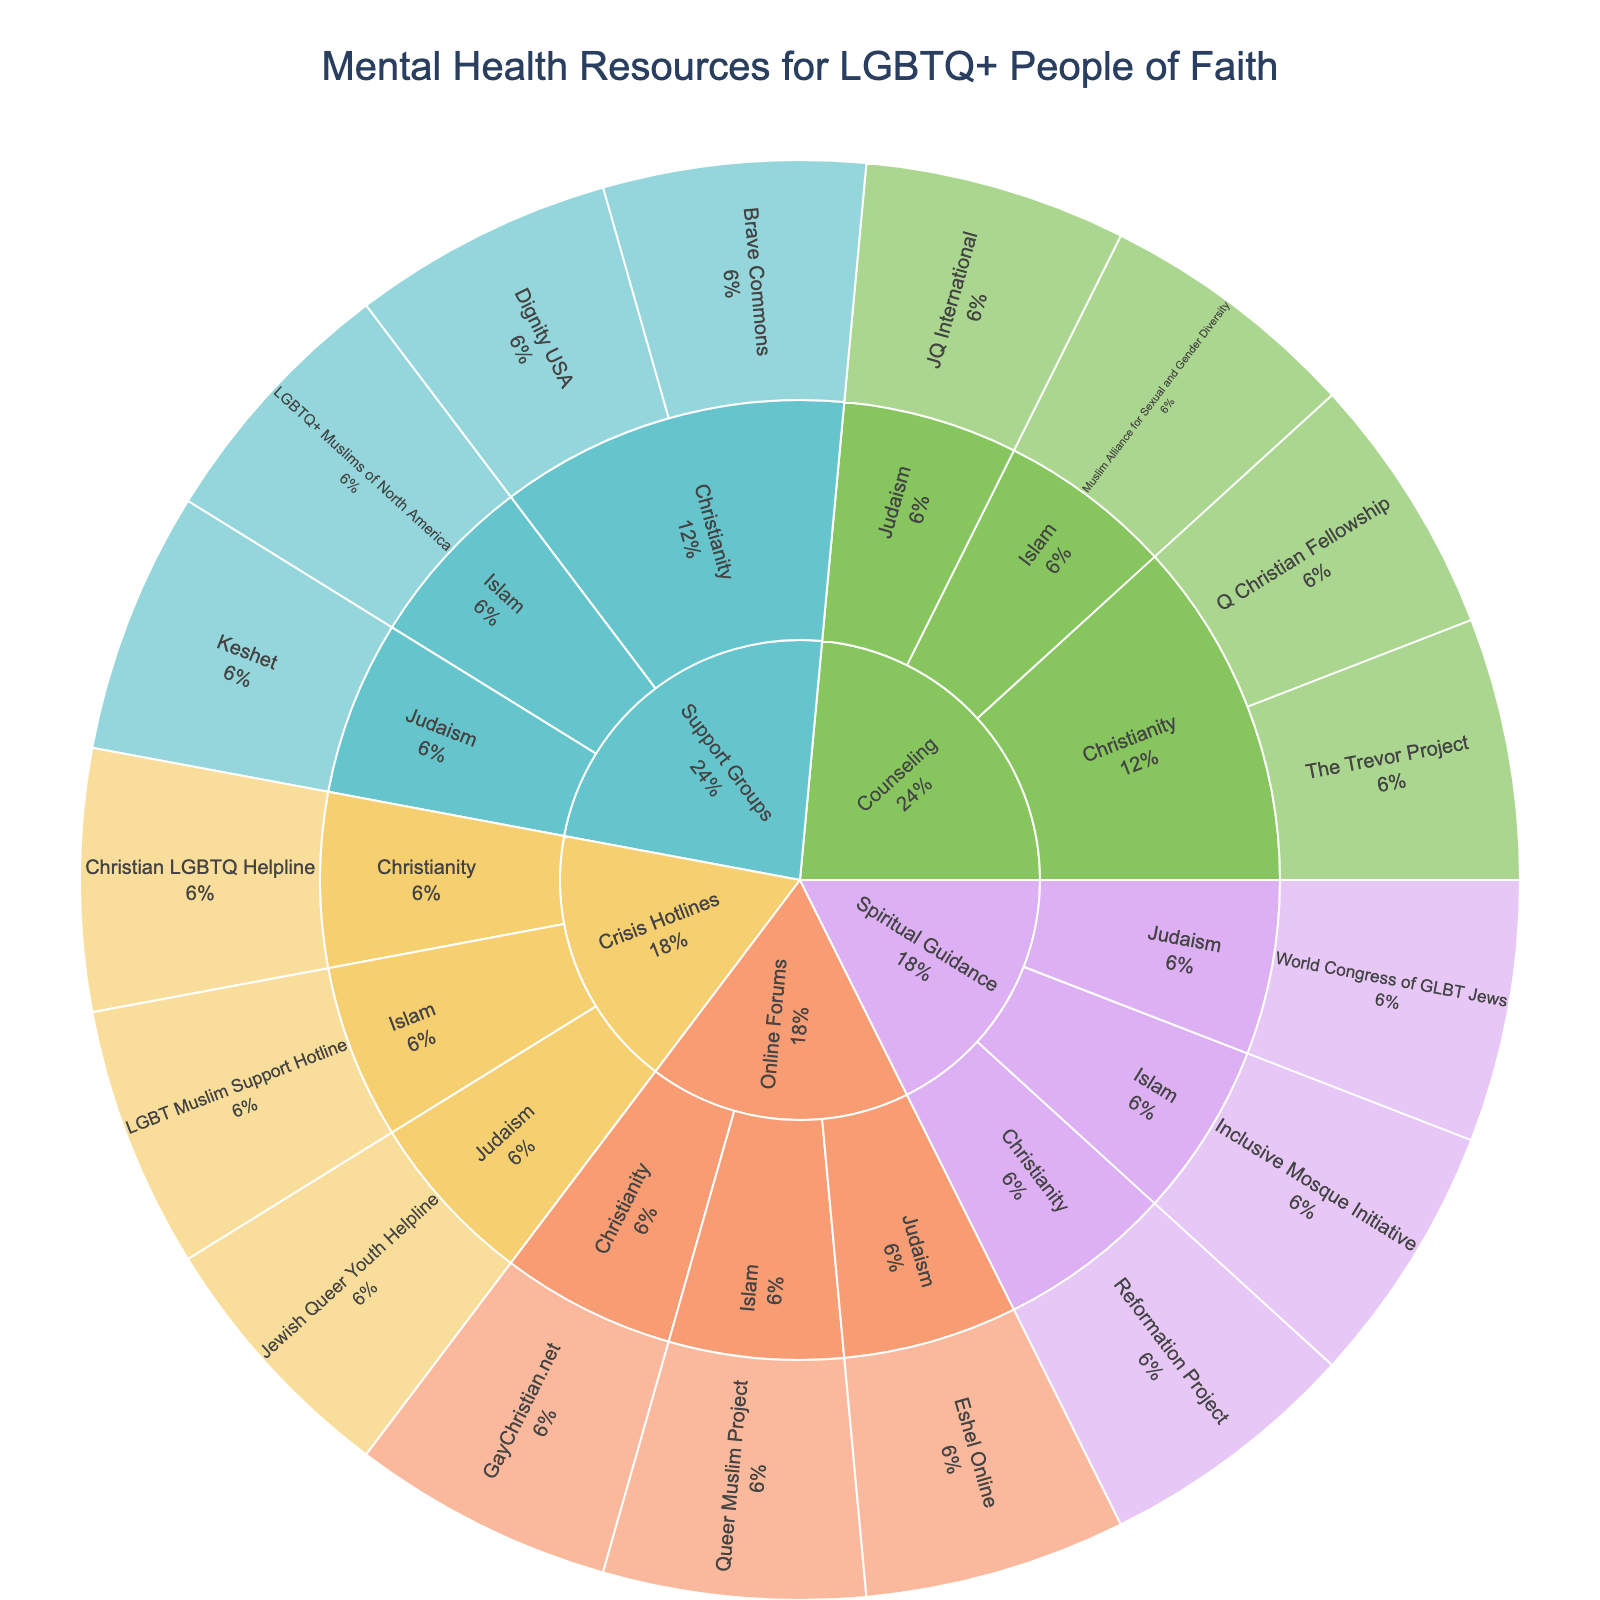How many types of support are shown in the figure? The figure is divided into sections based on different types of support for LGBTQ+ people of faith. By looking at the outermost ring, you can count the distinct segments.
Answer: 4 Which type of support has the most resources listed under Christianity? To answer this, you need to look at the size of the segments associated with Christianity under each type of support. Compare the segments to find the largest one.
Answer: Counseling Are there more resources listed under Judaism or Islam for crisis hotlines? To compare, look at the segments under crisis hotlines for both Judaism and Islam. Count the resources for each and compare the numbers.
Answer: Judaism Which resource provides spiritual guidance for LGBTQ+ Muslims? Focus on the segment labeled "Spiritual Guidance" and then find the subdivision under Islam. The resource listed there is the answer.
Answer: Inclusive Mosque Initiative What is the percentage of resources provided for support groups under Christianity? Locate the segment for Christianity under support groups and note the percentage. The Sunburst Plot typically provides this information in the label.
Answer: Approximately 25% Count the total number of resources listed across all types of support for Islam. Sum the number of resources found in all segments under Islam, including counseling, support groups, spiritual guidance, online forums, and crisis hotlines.
Answer: 5 Which type of support has the least resources listed under Judaism? Check each segment under Judaism for different types of support and identify the one with the smallest area (or the fewest resources listed).
Answer: Counseling Among the support groups listed, which one serves LGBTQ+ Christians? Look at the segment labeled "Support Groups" and find the subdivisions under Christianity. The resource names listed there are the answer.
Answer: Brave Commons, Dignity USA Is there any type of support exclusive to only one religious affiliation? If so, identify them. Examine each type of support and see if any segment is subdivided into just one religious affiliation, meaning it doesn't branch into multiple affiliations.
Answer: No, all support types serve multiple affiliations Compare the total number of resources listed for online forums across all religious affiliations. Count the number of resources listed under online forums for each religious group and sum them up to get the total.
Answer: 3 